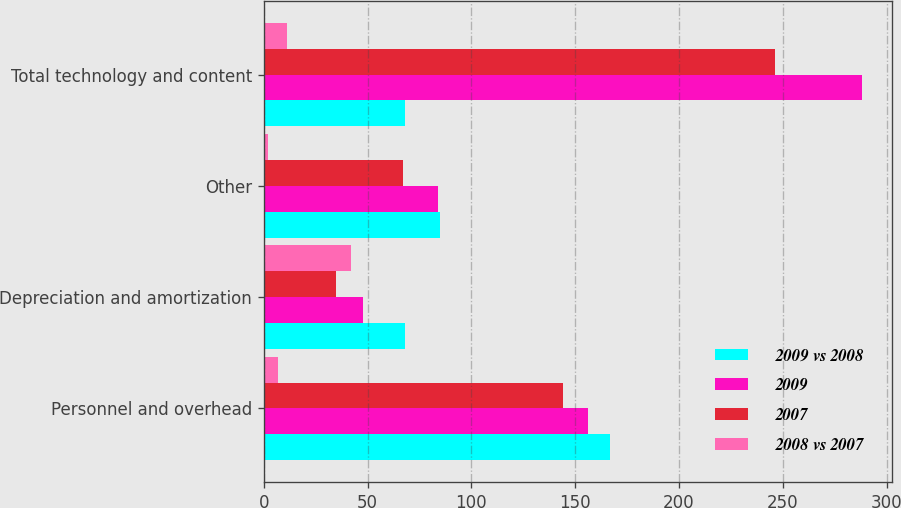Convert chart to OTSL. <chart><loc_0><loc_0><loc_500><loc_500><stacked_bar_chart><ecel><fcel>Personnel and overhead<fcel>Depreciation and amortization<fcel>Other<fcel>Total technology and content<nl><fcel>2009 vs 2008<fcel>167<fcel>68<fcel>85<fcel>68<nl><fcel>2009<fcel>156<fcel>48<fcel>84<fcel>288<nl><fcel>2007<fcel>144<fcel>35<fcel>67<fcel>246<nl><fcel>2008 vs 2007<fcel>7<fcel>42<fcel>2<fcel>11<nl></chart> 